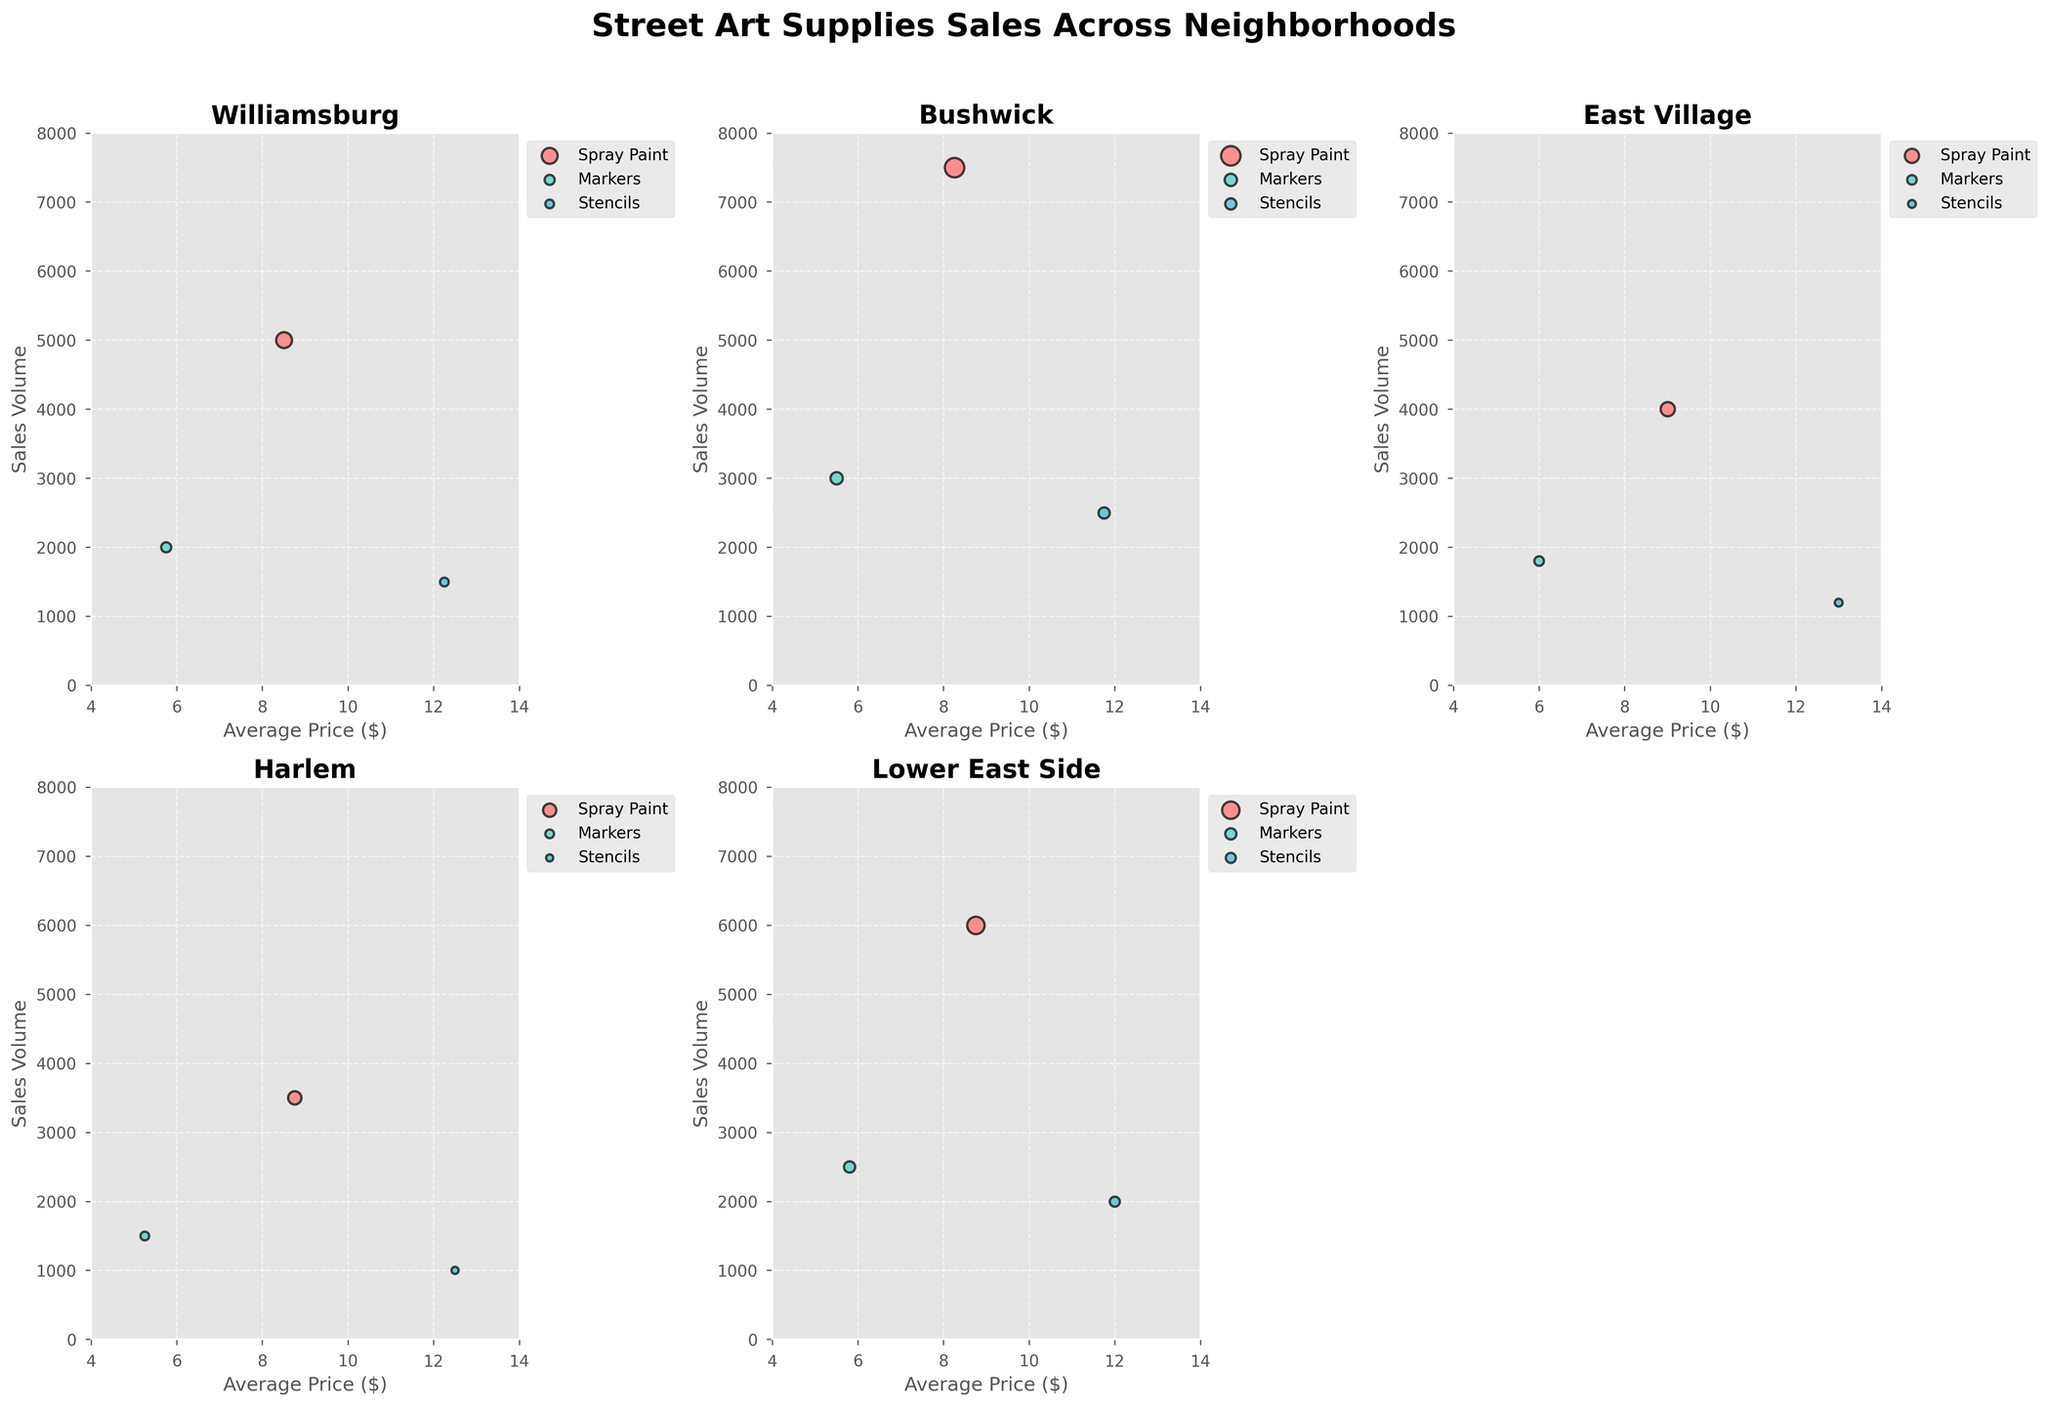What is the title of the plot? The plot title is located at the top and often gives a general understanding of what the plot is about. It reads: "Street Art Supplies Sales Across Neighborhoods".
Answer: Street Art Supplies Sales Across Neighborhoods Which neighborhood has the highest sales volume for spray paint? To determine this, look at the highest point on the y-axis for spray paint in each neighborhood's subplot. Bushwick has the highest point for spray paint (7500).
Answer: Bushwick What is the average price of markers in East Village? The average price for markers in East Village can be found on the x-axis in the East Village subplot. It is marked as 6.00.
Answer: 6.00 Compare the sales volume of stencils between Williamsburg and Harlem. Which one is higher? For this, compare the y-axis values of stencils in both Williamsburg and Harlem subplots. Williamsburg has a sales volume of 1500, while Harlem has 1000. Therefore, Williamsburg is higher.
Answer: Williamsburg Which product category in Bushwick has the lowest average price? To find this, look at the x-axis in the Bushwick subplot and identify the lowest average price among the categories. Markers have the lowest average price, which is 5.50.
Answer: Markers What is the color used for representing spray paint in the plots? The colors of the bubbles represent different product categories. The color of the spray paint bubbles needs to be identified across all subplots, which is a reddish hue.
Answer: Red How does the sales volume of markers in Lower East Side compare to East Village? Compare the y-axis values for markers in the Lower East Side subplot (2500) and East Village subplot (1800). Lower East Side has a higher sales volume.
Answer: Lower East Side Determine the average price range for stencils across all neighborhoods. Look at the x-axis positions of stencils in each subplot. The average prices range from 11.75 to 13.00.
Answer: 11.75 to 13.00 What is the relationship between average price and sales volume for spray paint? Observing all the subplots, there seems to be no clear linear relationship. Higher average prices do not consistently correlate with higher sales volumes.
Answer: No clear relationship 